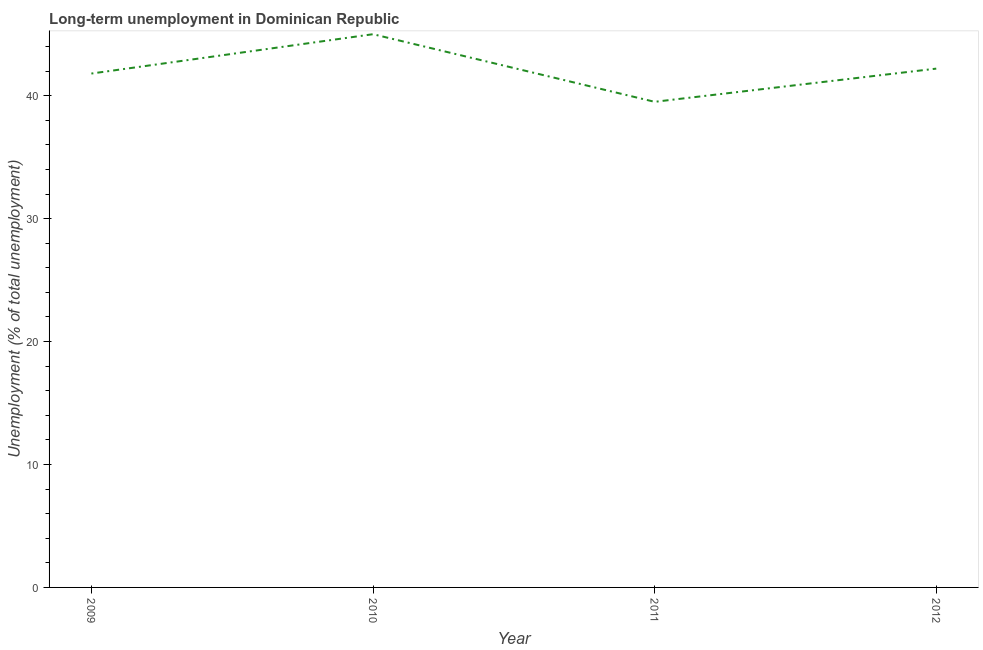What is the long-term unemployment in 2009?
Offer a terse response. 41.8. Across all years, what is the maximum long-term unemployment?
Your response must be concise. 45. Across all years, what is the minimum long-term unemployment?
Your response must be concise. 39.5. In which year was the long-term unemployment minimum?
Provide a succinct answer. 2011. What is the sum of the long-term unemployment?
Make the answer very short. 168.5. What is the difference between the long-term unemployment in 2009 and 2012?
Your answer should be very brief. -0.4. What is the average long-term unemployment per year?
Keep it short and to the point. 42.12. What is the median long-term unemployment?
Give a very brief answer. 42. In how many years, is the long-term unemployment greater than 6 %?
Make the answer very short. 4. Do a majority of the years between 2010 and 2012 (inclusive) have long-term unemployment greater than 22 %?
Make the answer very short. Yes. What is the ratio of the long-term unemployment in 2009 to that in 2012?
Provide a short and direct response. 0.99. What is the difference between the highest and the second highest long-term unemployment?
Your response must be concise. 2.8. What is the difference between the highest and the lowest long-term unemployment?
Make the answer very short. 5.5. In how many years, is the long-term unemployment greater than the average long-term unemployment taken over all years?
Your answer should be compact. 2. How many lines are there?
Provide a succinct answer. 1. How many years are there in the graph?
Provide a succinct answer. 4. Are the values on the major ticks of Y-axis written in scientific E-notation?
Your response must be concise. No. Does the graph contain any zero values?
Make the answer very short. No. What is the title of the graph?
Keep it short and to the point. Long-term unemployment in Dominican Republic. What is the label or title of the X-axis?
Your answer should be very brief. Year. What is the label or title of the Y-axis?
Offer a very short reply. Unemployment (% of total unemployment). What is the Unemployment (% of total unemployment) in 2009?
Keep it short and to the point. 41.8. What is the Unemployment (% of total unemployment) in 2010?
Provide a succinct answer. 45. What is the Unemployment (% of total unemployment) of 2011?
Ensure brevity in your answer.  39.5. What is the Unemployment (% of total unemployment) of 2012?
Give a very brief answer. 42.2. What is the difference between the Unemployment (% of total unemployment) in 2009 and 2011?
Offer a very short reply. 2.3. What is the difference between the Unemployment (% of total unemployment) in 2010 and 2011?
Make the answer very short. 5.5. What is the difference between the Unemployment (% of total unemployment) in 2011 and 2012?
Your response must be concise. -2.7. What is the ratio of the Unemployment (% of total unemployment) in 2009 to that in 2010?
Your answer should be very brief. 0.93. What is the ratio of the Unemployment (% of total unemployment) in 2009 to that in 2011?
Your answer should be very brief. 1.06. What is the ratio of the Unemployment (% of total unemployment) in 2010 to that in 2011?
Give a very brief answer. 1.14. What is the ratio of the Unemployment (% of total unemployment) in 2010 to that in 2012?
Offer a terse response. 1.07. What is the ratio of the Unemployment (% of total unemployment) in 2011 to that in 2012?
Ensure brevity in your answer.  0.94. 